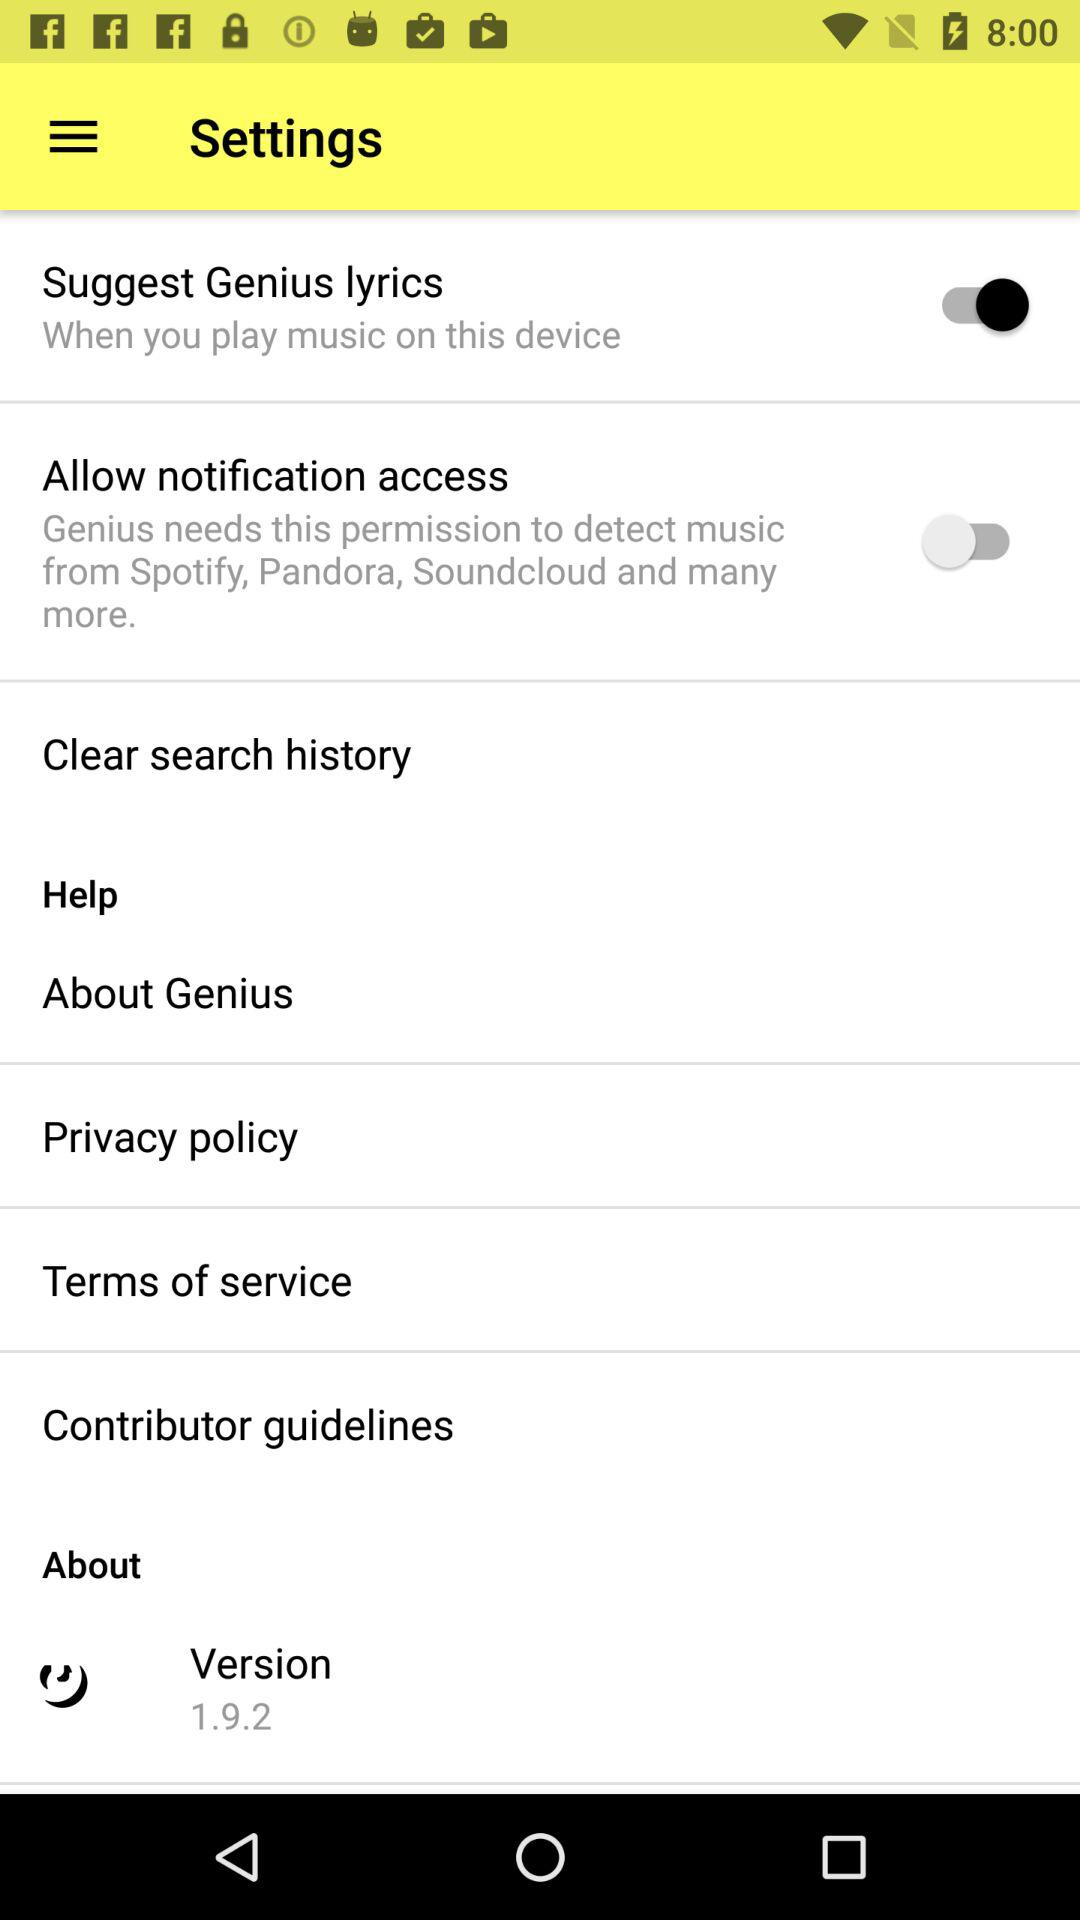How many items allow users to enable or disable features?
Answer the question using a single word or phrase. 2 